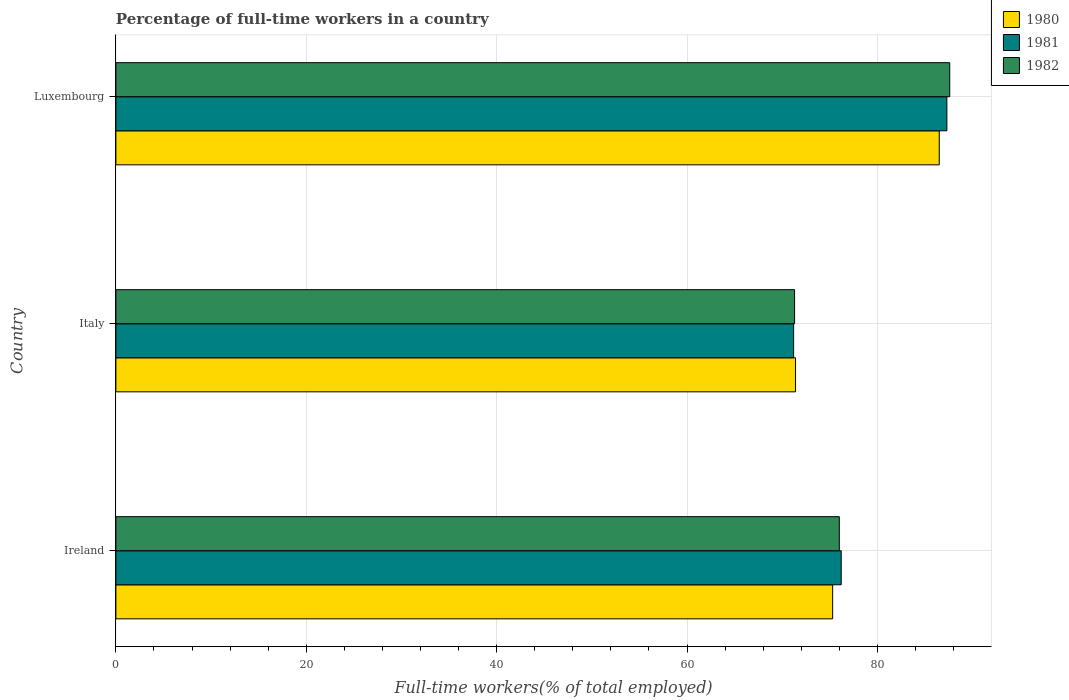How many groups of bars are there?
Offer a very short reply. 3. Are the number of bars per tick equal to the number of legend labels?
Make the answer very short. Yes. Are the number of bars on each tick of the Y-axis equal?
Offer a very short reply. Yes. What is the label of the 1st group of bars from the top?
Your answer should be compact. Luxembourg. What is the percentage of full-time workers in 1981 in Luxembourg?
Keep it short and to the point. 87.3. Across all countries, what is the maximum percentage of full-time workers in 1982?
Your answer should be compact. 87.6. Across all countries, what is the minimum percentage of full-time workers in 1980?
Offer a very short reply. 71.4. In which country was the percentage of full-time workers in 1982 maximum?
Offer a very short reply. Luxembourg. What is the total percentage of full-time workers in 1982 in the graph?
Offer a very short reply. 234.9. What is the difference between the percentage of full-time workers in 1980 in Italy and the percentage of full-time workers in 1982 in Luxembourg?
Your answer should be compact. -16.2. What is the average percentage of full-time workers in 1982 per country?
Provide a short and direct response. 78.3. What is the difference between the percentage of full-time workers in 1982 and percentage of full-time workers in 1981 in Luxembourg?
Ensure brevity in your answer.  0.3. In how many countries, is the percentage of full-time workers in 1982 greater than 12 %?
Make the answer very short. 3. What is the ratio of the percentage of full-time workers in 1981 in Ireland to that in Italy?
Make the answer very short. 1.07. What is the difference between the highest and the second highest percentage of full-time workers in 1981?
Your answer should be very brief. 11.1. What is the difference between the highest and the lowest percentage of full-time workers in 1981?
Make the answer very short. 16.1. In how many countries, is the percentage of full-time workers in 1980 greater than the average percentage of full-time workers in 1980 taken over all countries?
Your response must be concise. 1. Is the sum of the percentage of full-time workers in 1982 in Ireland and Luxembourg greater than the maximum percentage of full-time workers in 1981 across all countries?
Provide a short and direct response. Yes. How many bars are there?
Provide a short and direct response. 9. Are all the bars in the graph horizontal?
Your answer should be very brief. Yes. How many countries are there in the graph?
Offer a very short reply. 3. What is the difference between two consecutive major ticks on the X-axis?
Offer a terse response. 20. Does the graph contain any zero values?
Offer a terse response. No. Does the graph contain grids?
Your answer should be very brief. Yes. How many legend labels are there?
Ensure brevity in your answer.  3. How are the legend labels stacked?
Give a very brief answer. Vertical. What is the title of the graph?
Make the answer very short. Percentage of full-time workers in a country. Does "1997" appear as one of the legend labels in the graph?
Make the answer very short. No. What is the label or title of the X-axis?
Make the answer very short. Full-time workers(% of total employed). What is the Full-time workers(% of total employed) of 1980 in Ireland?
Provide a short and direct response. 75.3. What is the Full-time workers(% of total employed) of 1981 in Ireland?
Provide a succinct answer. 76.2. What is the Full-time workers(% of total employed) in 1980 in Italy?
Provide a succinct answer. 71.4. What is the Full-time workers(% of total employed) in 1981 in Italy?
Give a very brief answer. 71.2. What is the Full-time workers(% of total employed) in 1982 in Italy?
Your answer should be very brief. 71.3. What is the Full-time workers(% of total employed) in 1980 in Luxembourg?
Offer a terse response. 86.5. What is the Full-time workers(% of total employed) of 1981 in Luxembourg?
Offer a very short reply. 87.3. What is the Full-time workers(% of total employed) in 1982 in Luxembourg?
Provide a short and direct response. 87.6. Across all countries, what is the maximum Full-time workers(% of total employed) of 1980?
Offer a very short reply. 86.5. Across all countries, what is the maximum Full-time workers(% of total employed) in 1981?
Your answer should be compact. 87.3. Across all countries, what is the maximum Full-time workers(% of total employed) of 1982?
Make the answer very short. 87.6. Across all countries, what is the minimum Full-time workers(% of total employed) in 1980?
Your response must be concise. 71.4. Across all countries, what is the minimum Full-time workers(% of total employed) in 1981?
Your answer should be compact. 71.2. Across all countries, what is the minimum Full-time workers(% of total employed) of 1982?
Your answer should be very brief. 71.3. What is the total Full-time workers(% of total employed) in 1980 in the graph?
Offer a very short reply. 233.2. What is the total Full-time workers(% of total employed) in 1981 in the graph?
Your answer should be very brief. 234.7. What is the total Full-time workers(% of total employed) in 1982 in the graph?
Provide a short and direct response. 234.9. What is the difference between the Full-time workers(% of total employed) in 1980 in Ireland and that in Italy?
Ensure brevity in your answer.  3.9. What is the difference between the Full-time workers(% of total employed) of 1981 in Ireland and that in Italy?
Offer a very short reply. 5. What is the difference between the Full-time workers(% of total employed) in 1982 in Ireland and that in Italy?
Provide a succinct answer. 4.7. What is the difference between the Full-time workers(% of total employed) in 1981 in Ireland and that in Luxembourg?
Your answer should be very brief. -11.1. What is the difference between the Full-time workers(% of total employed) of 1980 in Italy and that in Luxembourg?
Offer a terse response. -15.1. What is the difference between the Full-time workers(% of total employed) in 1981 in Italy and that in Luxembourg?
Keep it short and to the point. -16.1. What is the difference between the Full-time workers(% of total employed) of 1982 in Italy and that in Luxembourg?
Provide a short and direct response. -16.3. What is the difference between the Full-time workers(% of total employed) in 1981 in Ireland and the Full-time workers(% of total employed) in 1982 in Italy?
Your answer should be very brief. 4.9. What is the difference between the Full-time workers(% of total employed) in 1980 in Ireland and the Full-time workers(% of total employed) in 1981 in Luxembourg?
Provide a short and direct response. -12. What is the difference between the Full-time workers(% of total employed) in 1980 in Ireland and the Full-time workers(% of total employed) in 1982 in Luxembourg?
Offer a terse response. -12.3. What is the difference between the Full-time workers(% of total employed) of 1980 in Italy and the Full-time workers(% of total employed) of 1981 in Luxembourg?
Provide a succinct answer. -15.9. What is the difference between the Full-time workers(% of total employed) of 1980 in Italy and the Full-time workers(% of total employed) of 1982 in Luxembourg?
Your answer should be compact. -16.2. What is the difference between the Full-time workers(% of total employed) in 1981 in Italy and the Full-time workers(% of total employed) in 1982 in Luxembourg?
Provide a succinct answer. -16.4. What is the average Full-time workers(% of total employed) in 1980 per country?
Give a very brief answer. 77.73. What is the average Full-time workers(% of total employed) of 1981 per country?
Keep it short and to the point. 78.23. What is the average Full-time workers(% of total employed) in 1982 per country?
Ensure brevity in your answer.  78.3. What is the difference between the Full-time workers(% of total employed) in 1980 and Full-time workers(% of total employed) in 1981 in Ireland?
Give a very brief answer. -0.9. What is the difference between the Full-time workers(% of total employed) in 1980 and Full-time workers(% of total employed) in 1982 in Ireland?
Give a very brief answer. -0.7. What is the difference between the Full-time workers(% of total employed) of 1981 and Full-time workers(% of total employed) of 1982 in Ireland?
Give a very brief answer. 0.2. What is the difference between the Full-time workers(% of total employed) in 1980 and Full-time workers(% of total employed) in 1981 in Italy?
Make the answer very short. 0.2. What is the difference between the Full-time workers(% of total employed) in 1981 and Full-time workers(% of total employed) in 1982 in Luxembourg?
Your answer should be compact. -0.3. What is the ratio of the Full-time workers(% of total employed) in 1980 in Ireland to that in Italy?
Offer a very short reply. 1.05. What is the ratio of the Full-time workers(% of total employed) in 1981 in Ireland to that in Italy?
Your answer should be compact. 1.07. What is the ratio of the Full-time workers(% of total employed) of 1982 in Ireland to that in Italy?
Your answer should be very brief. 1.07. What is the ratio of the Full-time workers(% of total employed) in 1980 in Ireland to that in Luxembourg?
Your response must be concise. 0.87. What is the ratio of the Full-time workers(% of total employed) in 1981 in Ireland to that in Luxembourg?
Your answer should be compact. 0.87. What is the ratio of the Full-time workers(% of total employed) in 1982 in Ireland to that in Luxembourg?
Provide a short and direct response. 0.87. What is the ratio of the Full-time workers(% of total employed) in 1980 in Italy to that in Luxembourg?
Make the answer very short. 0.83. What is the ratio of the Full-time workers(% of total employed) in 1981 in Italy to that in Luxembourg?
Ensure brevity in your answer.  0.82. What is the ratio of the Full-time workers(% of total employed) in 1982 in Italy to that in Luxembourg?
Provide a succinct answer. 0.81. What is the difference between the highest and the second highest Full-time workers(% of total employed) in 1980?
Offer a terse response. 11.2. What is the difference between the highest and the second highest Full-time workers(% of total employed) in 1982?
Offer a very short reply. 11.6. What is the difference between the highest and the lowest Full-time workers(% of total employed) of 1980?
Your answer should be compact. 15.1. What is the difference between the highest and the lowest Full-time workers(% of total employed) in 1981?
Your answer should be compact. 16.1. What is the difference between the highest and the lowest Full-time workers(% of total employed) of 1982?
Ensure brevity in your answer.  16.3. 